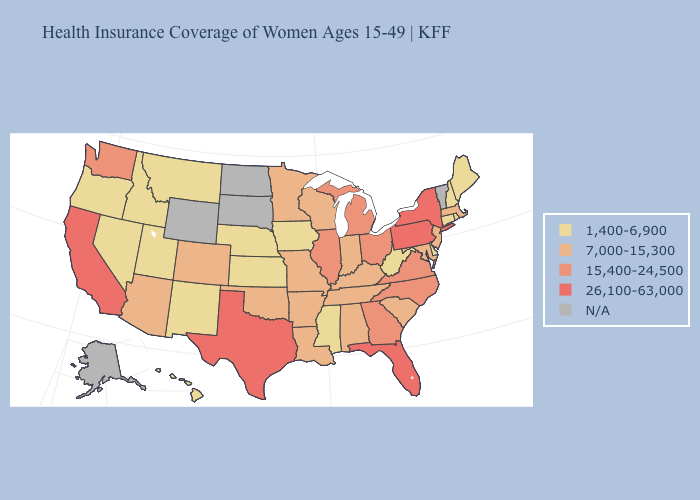What is the highest value in states that border Rhode Island?
Answer briefly. 7,000-15,300. What is the value of Missouri?
Quick response, please. 7,000-15,300. Does Mississippi have the highest value in the USA?
Keep it brief. No. What is the highest value in the South ?
Be succinct. 26,100-63,000. Does Oklahoma have the lowest value in the USA?
Answer briefly. No. Does Delaware have the highest value in the South?
Concise answer only. No. What is the value of North Dakota?
Be succinct. N/A. Does Oregon have the lowest value in the West?
Short answer required. Yes. What is the highest value in the MidWest ?
Concise answer only. 15,400-24,500. What is the value of Michigan?
Answer briefly. 15,400-24,500. Which states hav the highest value in the Northeast?
Concise answer only. New York, Pennsylvania. Name the states that have a value in the range N/A?
Answer briefly. Alaska, North Dakota, South Dakota, Vermont, Wyoming. What is the lowest value in the USA?
Write a very short answer. 1,400-6,900. Is the legend a continuous bar?
Quick response, please. No. 